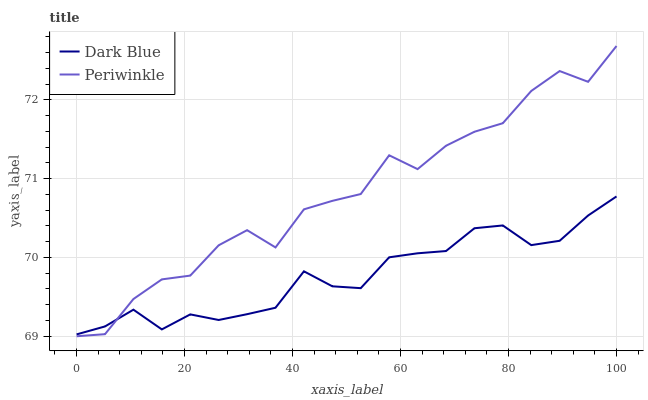Does Dark Blue have the minimum area under the curve?
Answer yes or no. Yes. Does Periwinkle have the maximum area under the curve?
Answer yes or no. Yes. Does Periwinkle have the minimum area under the curve?
Answer yes or no. No. Is Dark Blue the smoothest?
Answer yes or no. Yes. Is Periwinkle the roughest?
Answer yes or no. Yes. Is Periwinkle the smoothest?
Answer yes or no. No. Does Periwinkle have the lowest value?
Answer yes or no. Yes. Does Periwinkle have the highest value?
Answer yes or no. Yes. Does Dark Blue intersect Periwinkle?
Answer yes or no. Yes. Is Dark Blue less than Periwinkle?
Answer yes or no. No. Is Dark Blue greater than Periwinkle?
Answer yes or no. No. 